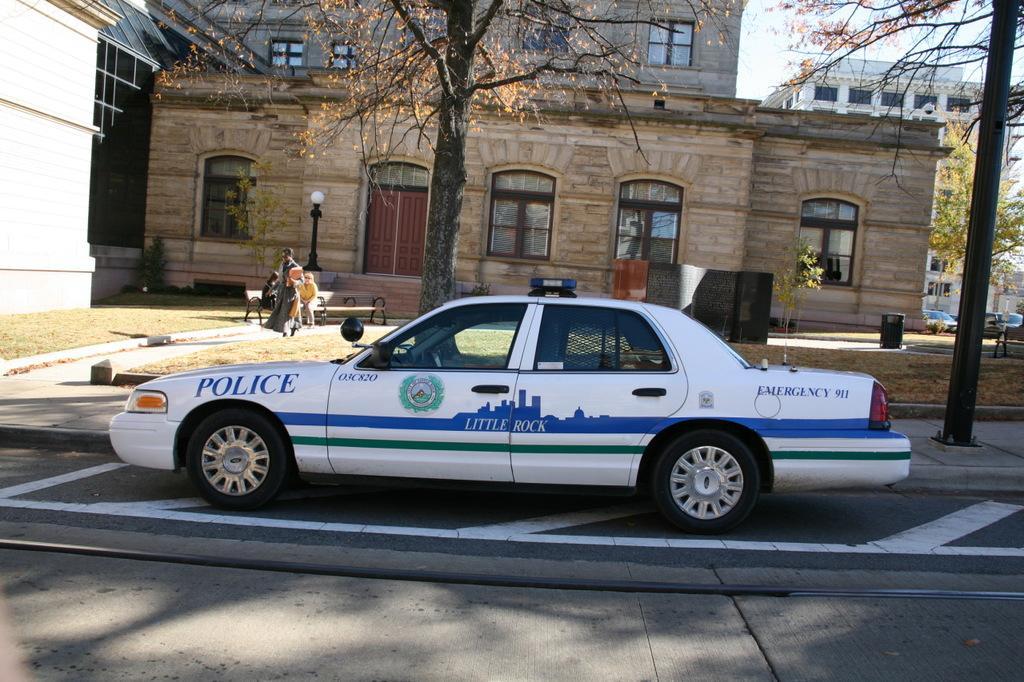Describe this image in one or two sentences. In the image there is a car in the foreground and behind the car there are trees, buildings and few people. 